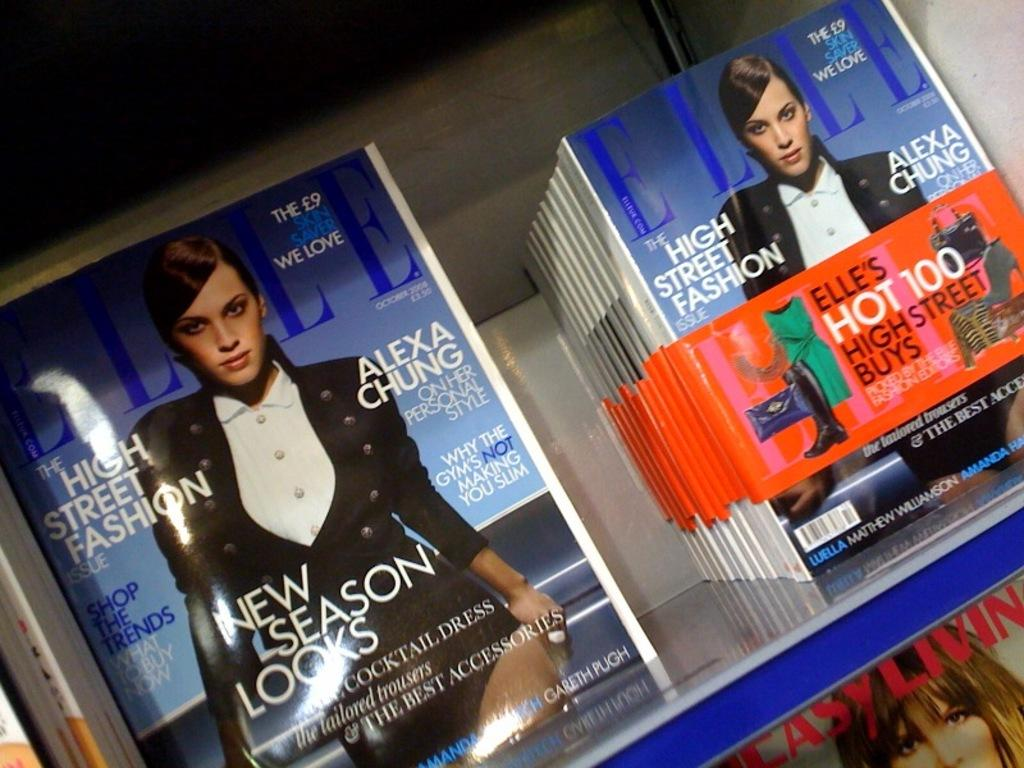<image>
Give a short and clear explanation of the subsequent image. Several copies of ELLE magazine with things written on it like ALEXA CHUNG and NEW SEASON LOOKS. 